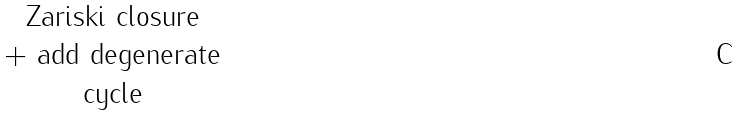Convert formula to latex. <formula><loc_0><loc_0><loc_500><loc_500>\begin{matrix} \text {Zariski closure} \\ \text {+ add degenerate} \\ \text {cycle} \end{matrix}</formula> 